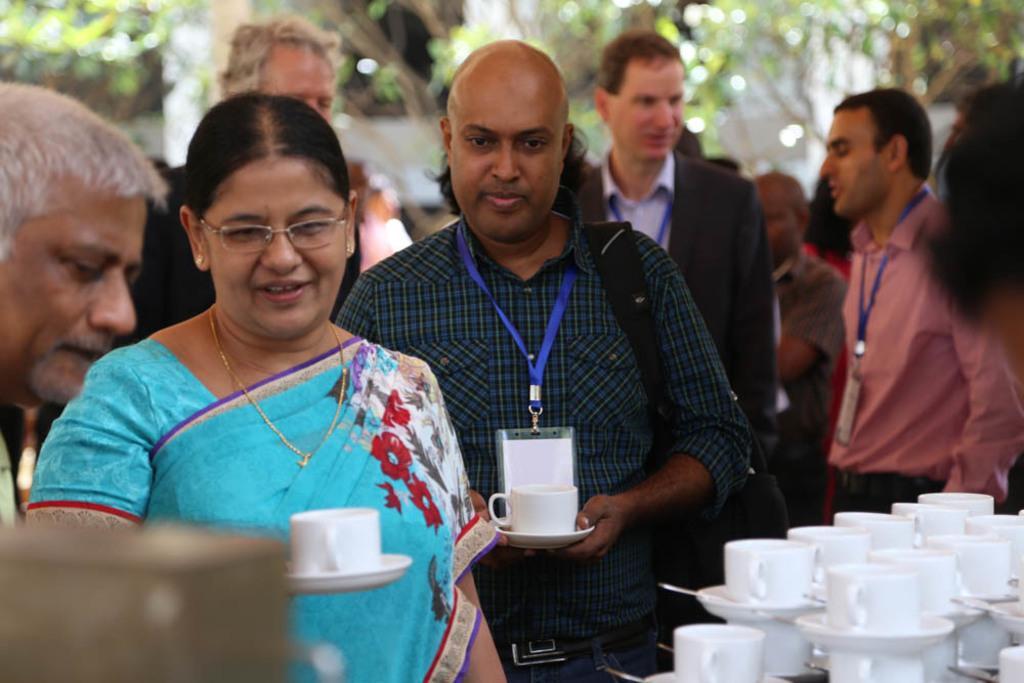How would you summarize this image in a sentence or two? In this picture i could some persons holding a cup and saucer in their hands. In the background i could see some trees around and in the right corner of the picture i could see cups and saucer arranged on each other with spoon in it. 